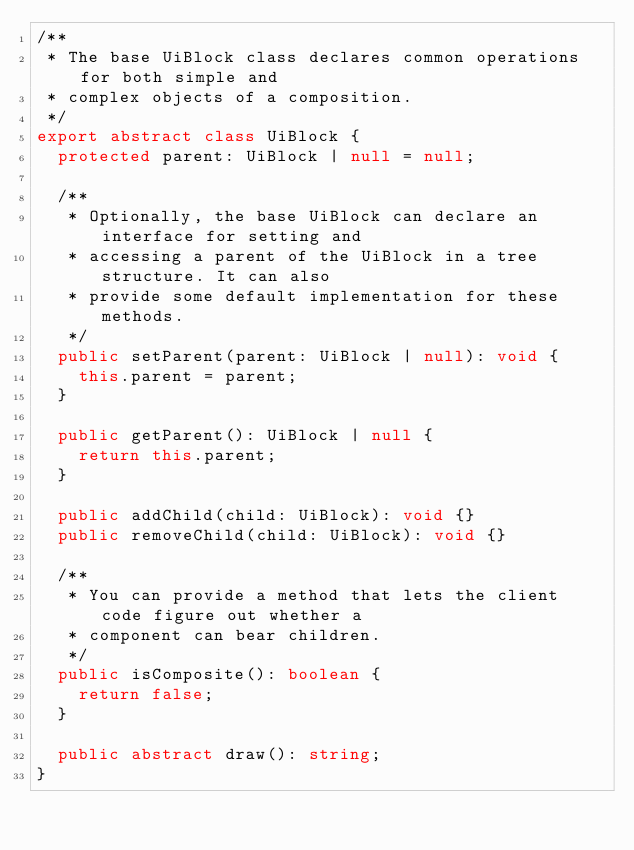<code> <loc_0><loc_0><loc_500><loc_500><_TypeScript_>/**
 * The base UiBlock class declares common operations for both simple and
 * complex objects of a composition.
 */
export abstract class UiBlock {
  protected parent: UiBlock | null = null;

  /**
   * Optionally, the base UiBlock can declare an interface for setting and
   * accessing a parent of the UiBlock in a tree structure. It can also
   * provide some default implementation for these methods.
   */
  public setParent(parent: UiBlock | null): void {
    this.parent = parent;
  }

  public getParent(): UiBlock | null {
    return this.parent;
  }

  public addChild(child: UiBlock): void {}
  public removeChild(child: UiBlock): void {}

  /**
   * You can provide a method that lets the client code figure out whether a
   * component can bear children.
   */
  public isComposite(): boolean {
    return false;
  }

  public abstract draw(): string;
}
</code> 